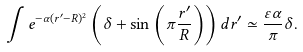<formula> <loc_0><loc_0><loc_500><loc_500>\int e ^ { - \alpha ( r ^ { \prime } - R ) ^ { 2 } } \left ( \delta + \sin \left ( \pi \frac { r ^ { \prime } } { R } \right ) \right ) d r ^ { \prime } \simeq \frac { \varepsilon \alpha } { \pi } \delta .</formula> 